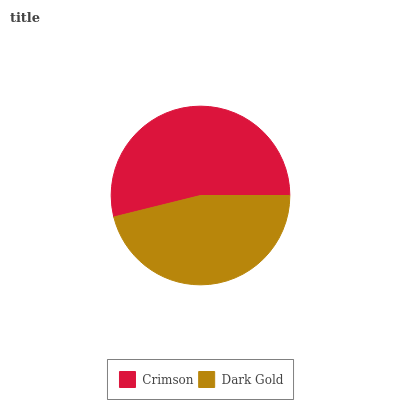Is Dark Gold the minimum?
Answer yes or no. Yes. Is Crimson the maximum?
Answer yes or no. Yes. Is Dark Gold the maximum?
Answer yes or no. No. Is Crimson greater than Dark Gold?
Answer yes or no. Yes. Is Dark Gold less than Crimson?
Answer yes or no. Yes. Is Dark Gold greater than Crimson?
Answer yes or no. No. Is Crimson less than Dark Gold?
Answer yes or no. No. Is Crimson the high median?
Answer yes or no. Yes. Is Dark Gold the low median?
Answer yes or no. Yes. Is Dark Gold the high median?
Answer yes or no. No. Is Crimson the low median?
Answer yes or no. No. 